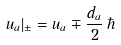<formula> <loc_0><loc_0><loc_500><loc_500>u _ { a } | _ { \pm } = u _ { a } \mp \frac { d _ { a } } { 2 } \, \hbar</formula> 